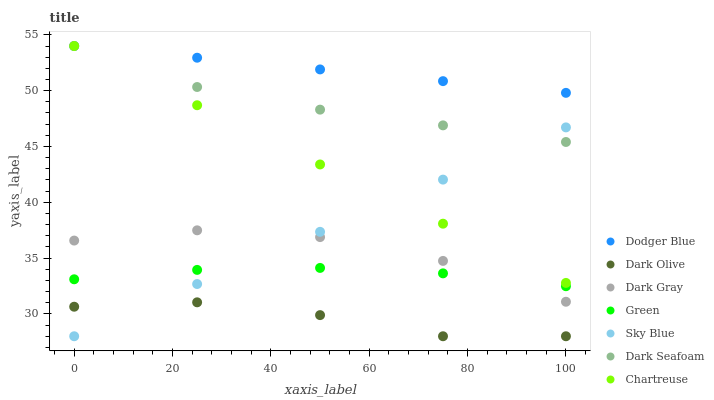Does Dark Olive have the minimum area under the curve?
Answer yes or no. Yes. Does Dodger Blue have the maximum area under the curve?
Answer yes or no. Yes. Does Chartreuse have the minimum area under the curve?
Answer yes or no. No. Does Chartreuse have the maximum area under the curve?
Answer yes or no. No. Is Sky Blue the smoothest?
Answer yes or no. Yes. Is Dark Gray the roughest?
Answer yes or no. Yes. Is Chartreuse the smoothest?
Answer yes or no. No. Is Chartreuse the roughest?
Answer yes or no. No. Does Dark Olive have the lowest value?
Answer yes or no. Yes. Does Chartreuse have the lowest value?
Answer yes or no. No. Does Dodger Blue have the highest value?
Answer yes or no. Yes. Does Dark Gray have the highest value?
Answer yes or no. No. Is Sky Blue less than Dodger Blue?
Answer yes or no. Yes. Is Chartreuse greater than Dark Gray?
Answer yes or no. Yes. Does Green intersect Sky Blue?
Answer yes or no. Yes. Is Green less than Sky Blue?
Answer yes or no. No. Is Green greater than Sky Blue?
Answer yes or no. No. Does Sky Blue intersect Dodger Blue?
Answer yes or no. No. 